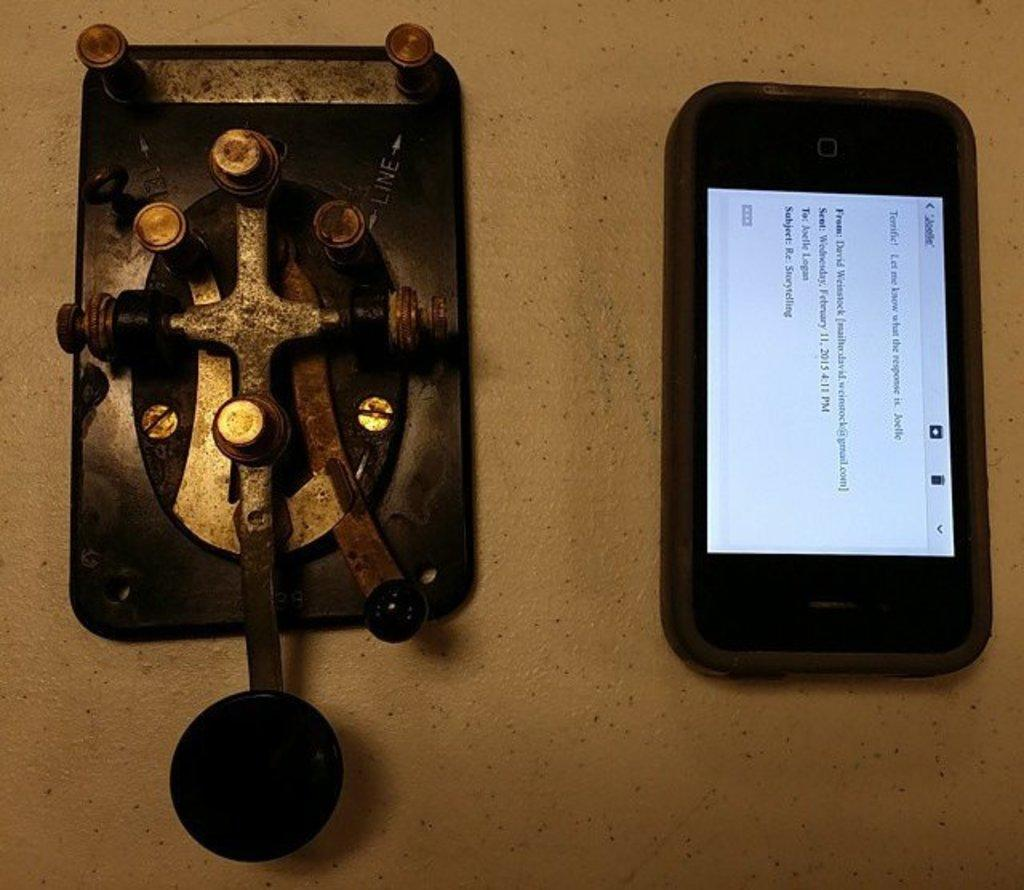What electronic device is visible in the image? There is a mobile phone in the image. What else can be seen on the surface in the image? The facts provided do not specify the objects on the surface, so we cannot answer that question definitively. How does the wax protect the mobile phone from the rainstorm in the image? There is no wax or rainstorm present in the image, so this question cannot be answered definitively. 